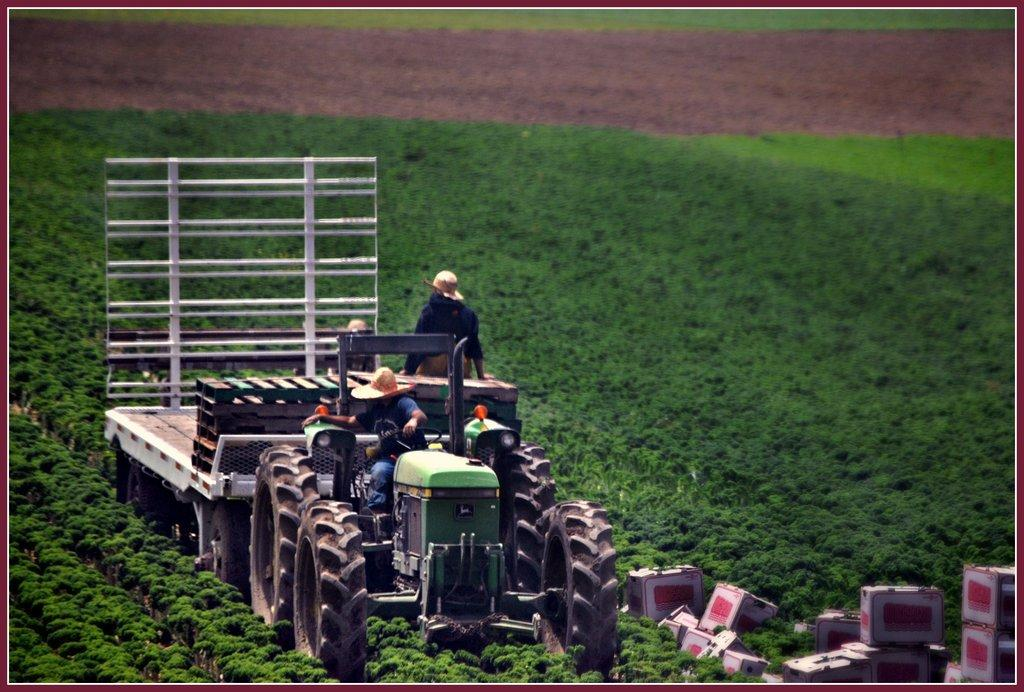What is the main subject of the image? There is a vehicle in the image. Are there any people present in the image? Yes, there are people in the image. What can be seen on the right side of the image? There are boxes on the right side of the image. What type of natural elements can be seen in the background of the image? There are plants visible in the background of the image. Can you hear a whistle in the image? There is no mention of a whistle in the image, so it cannot be heard. 